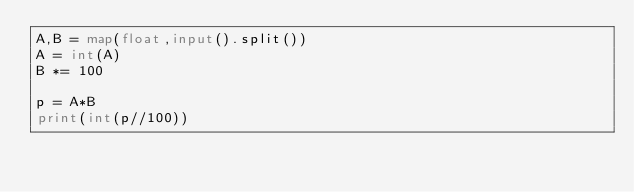Convert code to text. <code><loc_0><loc_0><loc_500><loc_500><_Python_>A,B = map(float,input().split())
A = int(A)
B *= 100

p = A*B
print(int(p//100))

</code> 